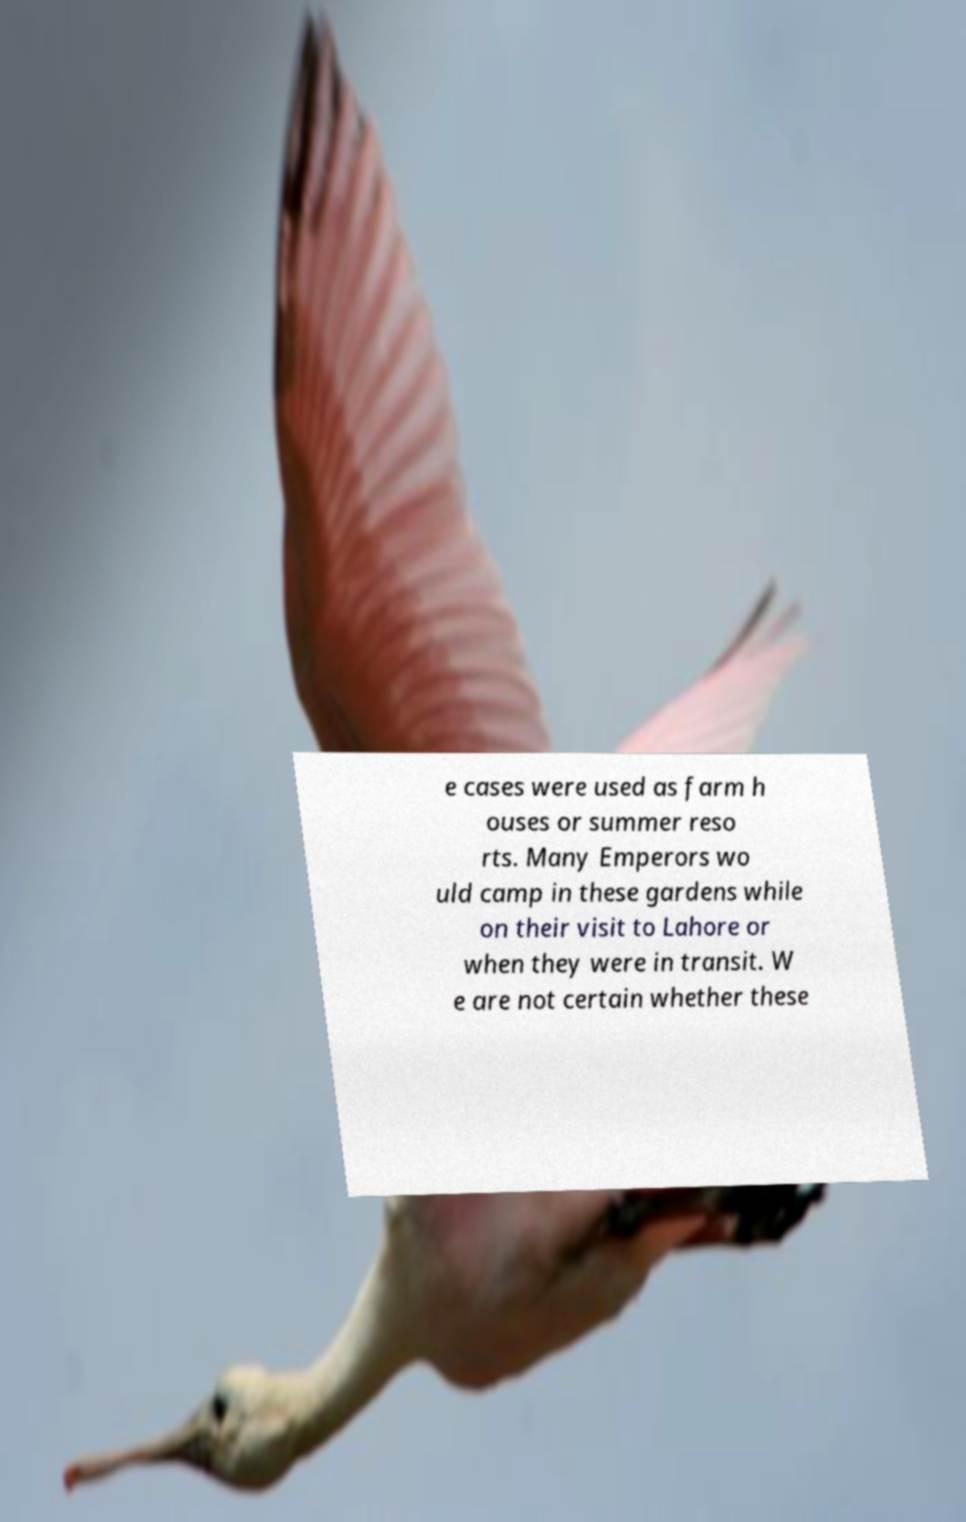Can you accurately transcribe the text from the provided image for me? e cases were used as farm h ouses or summer reso rts. Many Emperors wo uld camp in these gardens while on their visit to Lahore or when they were in transit. W e are not certain whether these 